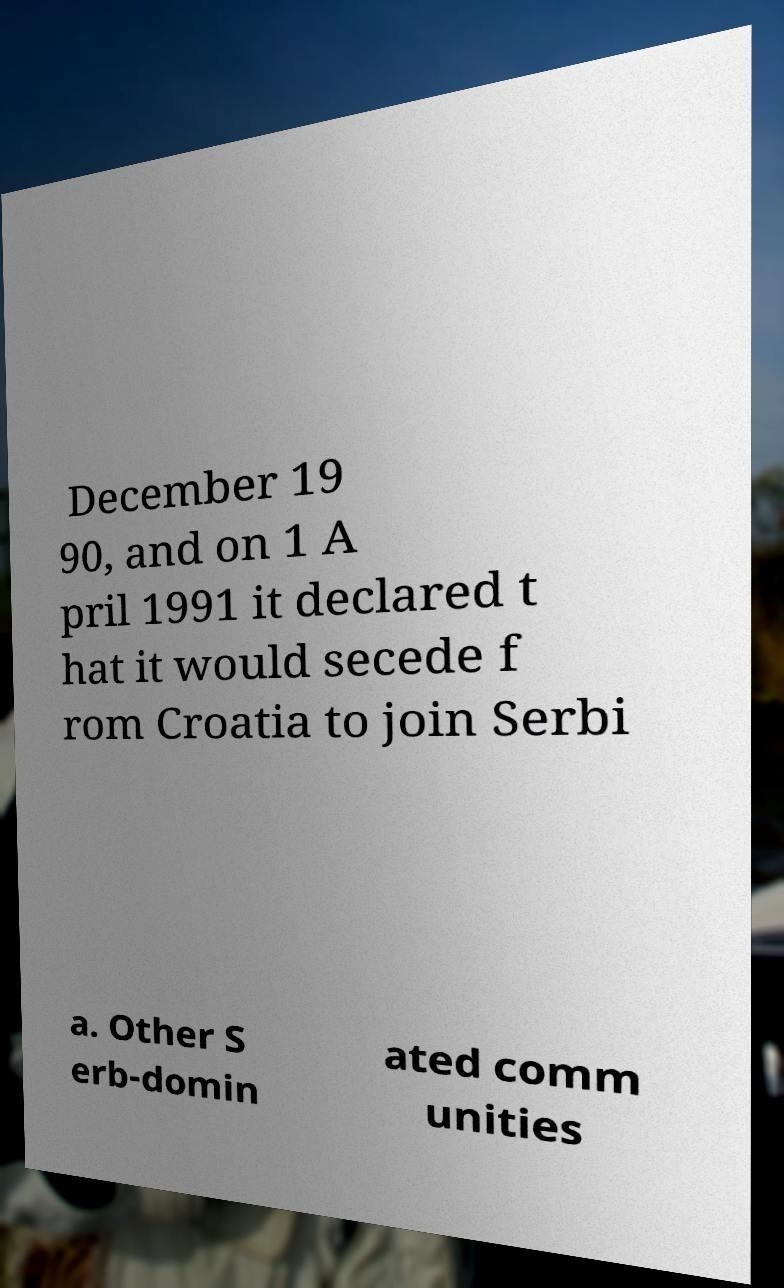Can you accurately transcribe the text from the provided image for me? December 19 90, and on 1 A pril 1991 it declared t hat it would secede f rom Croatia to join Serbi a. Other S erb-domin ated comm unities 